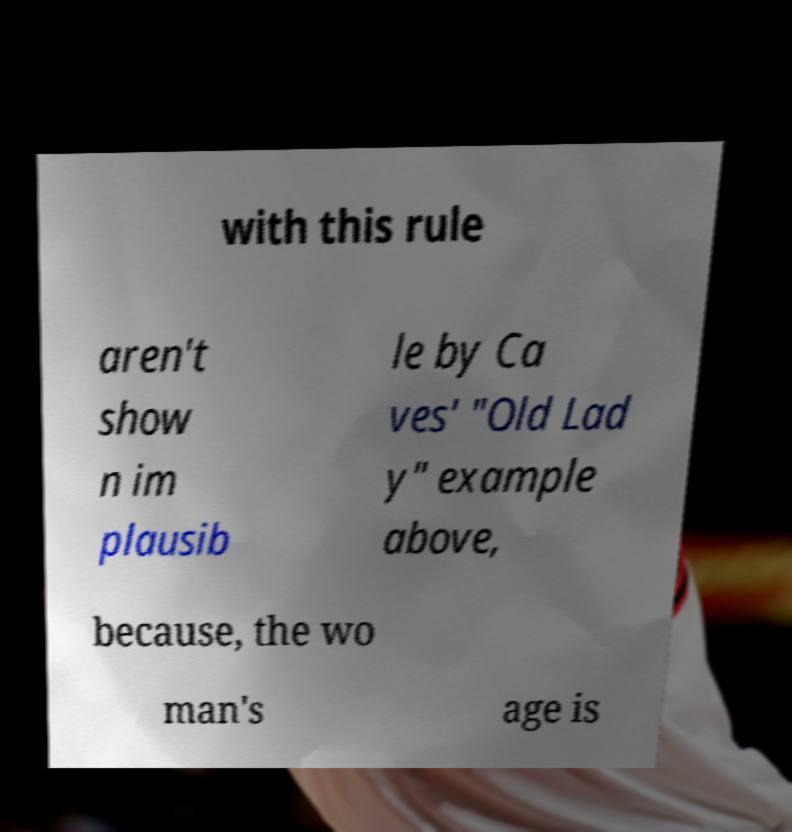Can you read and provide the text displayed in the image?This photo seems to have some interesting text. Can you extract and type it out for me? with this rule aren't show n im plausib le by Ca ves' "Old Lad y" example above, because, the wo man's age is 